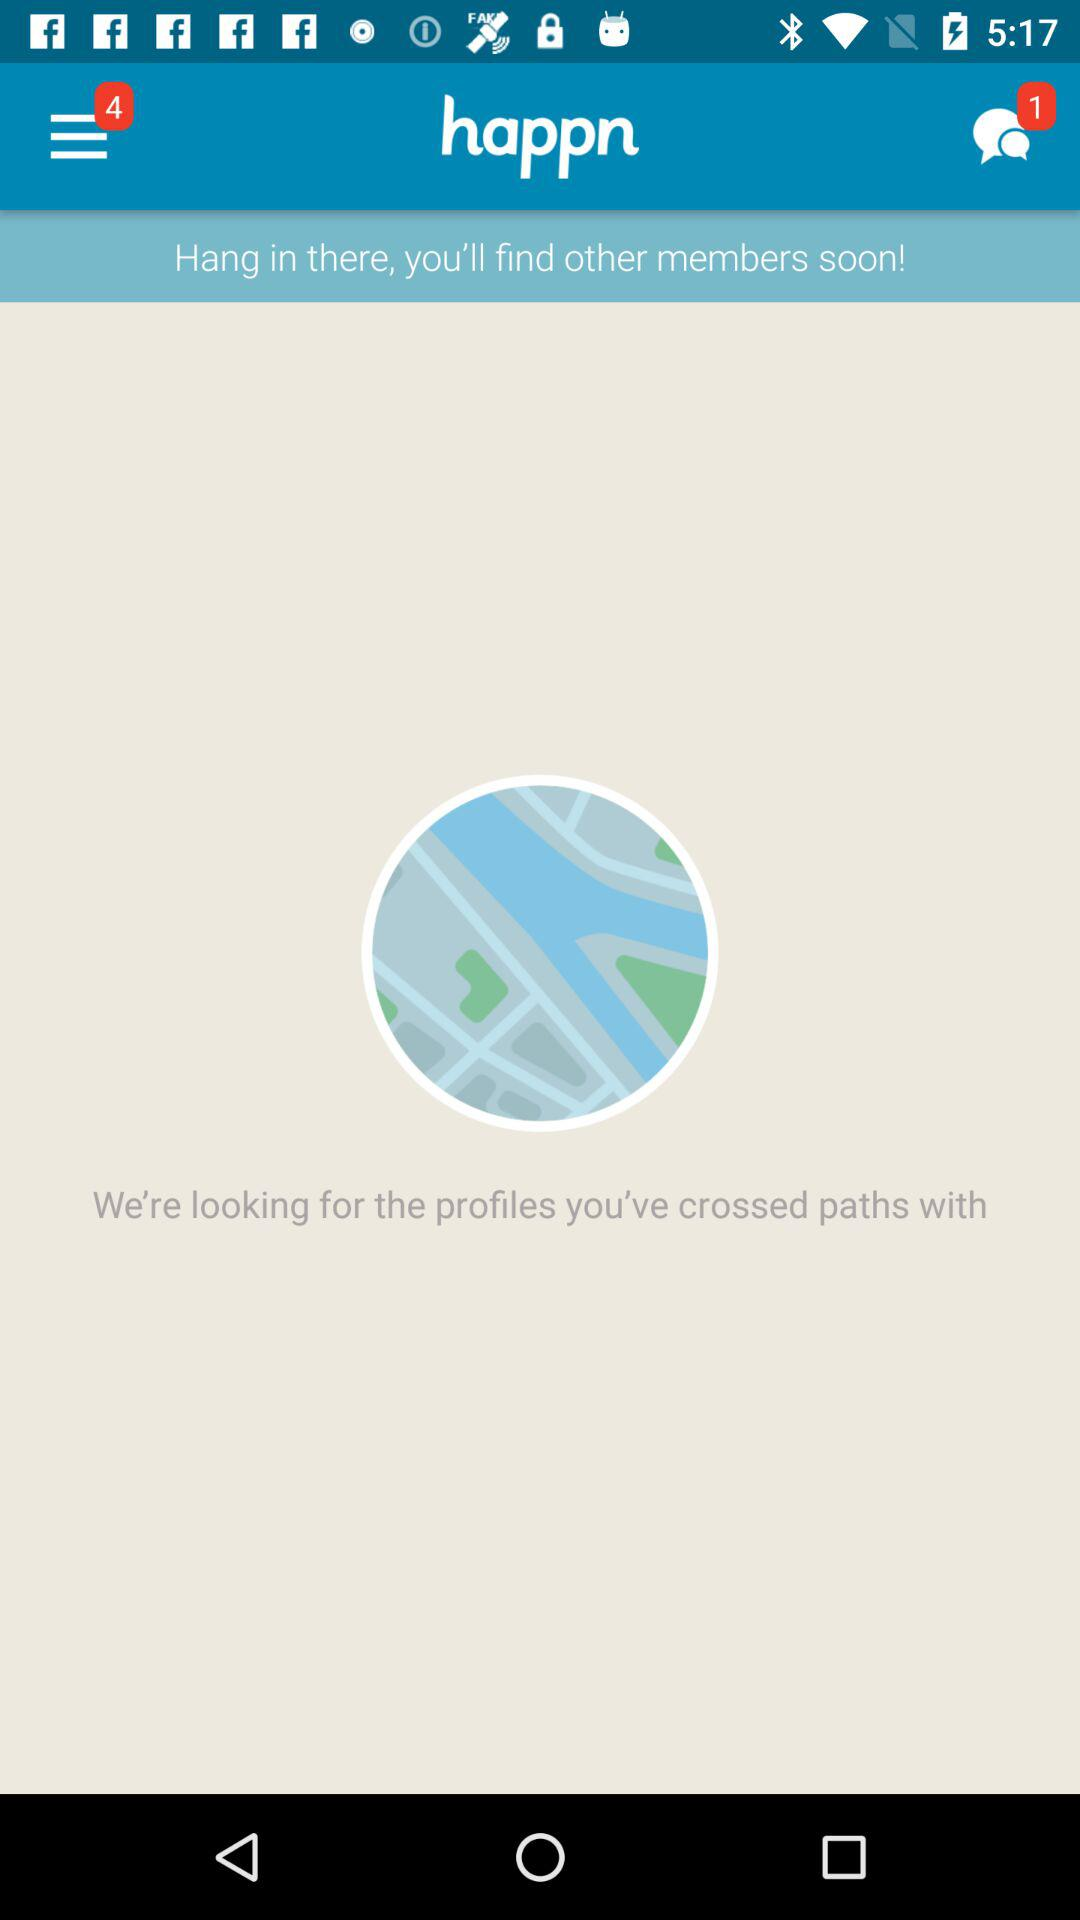What is the number of notifications on the menu? The number of notifications on the menu is 4. 